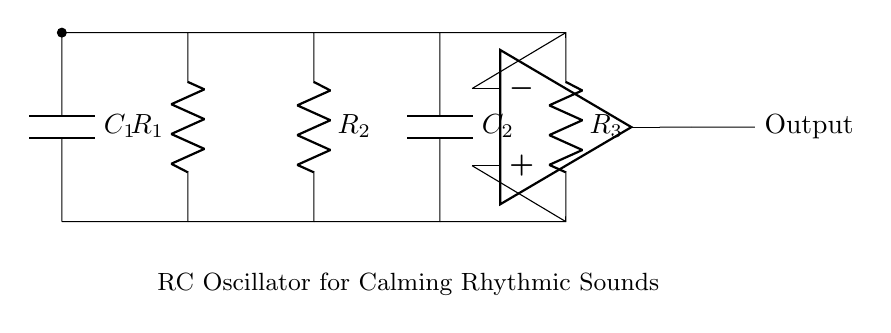What type of circuit is shown? The circuit is described as an RC oscillator, indicated by the arrangement of resistors and capacitors designed to produce oscillating signals.
Answer: RC oscillator How many resistors are in the circuit? By counting the components labeled as resistors in the diagram, there are three resistors labeled R1, R2, and R3.
Answer: Three What are the components connected in parallel? The capacitors C1 and C2 are connected in parallel with respect to the resistors and the op-amp, creating branches that share the same voltage across them.
Answer: C1 and C2 What is the purpose of the op-amp in this circuit? The op-amp amplifies the oscillating signals generated by the RC components, allowing the output to create a more substantial and clear oscillation suitable for sound generation.
Answer: Amplification What happens to the frequency when the value of the capacitor increases? Increasing the value of the capacitor typically decreases the frequency of oscillation because a larger capacitor takes longer to charge and discharge through the resistors.
Answer: Frequency decreases What role do resistors play in this oscillator circuit? The resistors work together with the capacitors to define the time constant of the circuit, influencing the charging and discharging cycle, which ultimately affects the oscillation frequency.
Answer: Time constant What is the output of the circuit labeled as? The output from the op-amp is labeled simply as "Output," indicating where the oscillating signal can be taken for use in generating sounds.
Answer: Output 